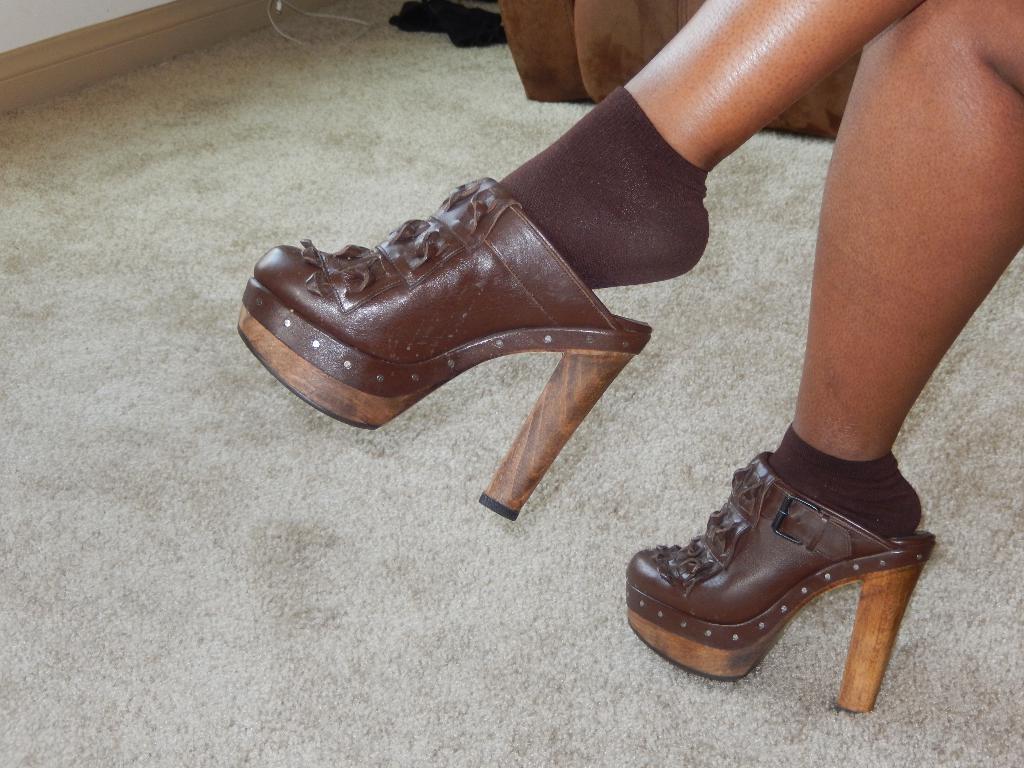Please provide a concise description of this image. In the image there is a person who is wearing brown colour socks and brown colour wooden hill boots. 